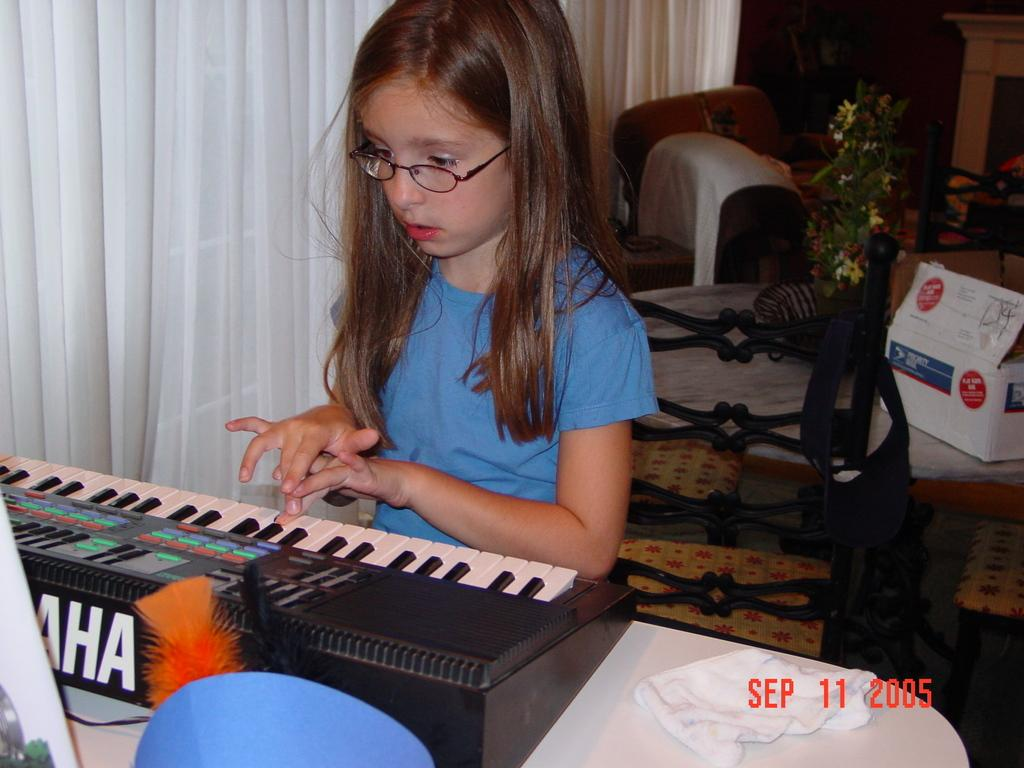Who is the main subject in the image? There is a girl in the image. What is the girl doing in the image? The girl is learning to play the piano. Can you describe the background of the image? There is a plant on a table in the background of the image. What type of lunch is the girl eating during her piano lesson? There is no indication in the image that the girl is eating lunch, as the focus is on her learning to play the piano. 